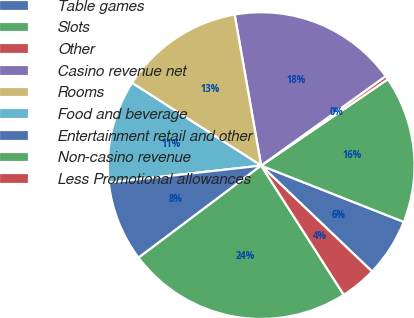Convert chart to OTSL. <chart><loc_0><loc_0><loc_500><loc_500><pie_chart><fcel>Table games<fcel>Slots<fcel>Other<fcel>Casino revenue net<fcel>Rooms<fcel>Food and beverage<fcel>Entertainment retail and other<fcel>Non-casino revenue<fcel>Less Promotional allowances<nl><fcel>6.15%<fcel>15.51%<fcel>0.39%<fcel>17.85%<fcel>13.17%<fcel>10.83%<fcel>8.49%<fcel>23.8%<fcel>3.81%<nl></chart> 